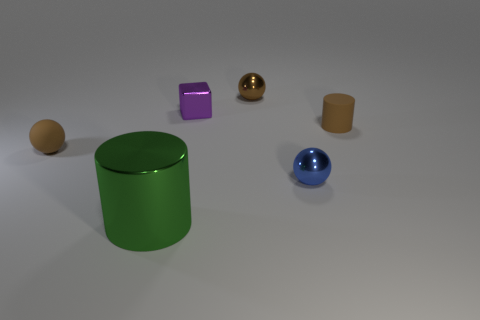What is the color of the cube?
Give a very brief answer. Purple. What color is the cube that is the same material as the large cylinder?
Ensure brevity in your answer.  Purple. What number of tiny brown cylinders have the same material as the blue thing?
Ensure brevity in your answer.  0. There is a tiny block; what number of large cylinders are to the right of it?
Give a very brief answer. 0. Do the tiny object on the left side of the tiny purple metal cube and the tiny blue object that is behind the green cylinder have the same material?
Ensure brevity in your answer.  No. Is the number of small brown metal things behind the tiny purple metallic object greater than the number of small purple shiny cubes on the right side of the small brown shiny object?
Your answer should be compact. Yes. There is another ball that is the same color as the small rubber ball; what is its material?
Offer a terse response. Metal. Is there anything else that has the same shape as the tiny purple thing?
Offer a terse response. No. There is a small brown object that is both in front of the brown metallic sphere and to the right of the small rubber ball; what is its material?
Your answer should be very brief. Rubber. Does the small purple thing have the same material as the brown sphere that is in front of the small brown cylinder?
Keep it short and to the point. No. 